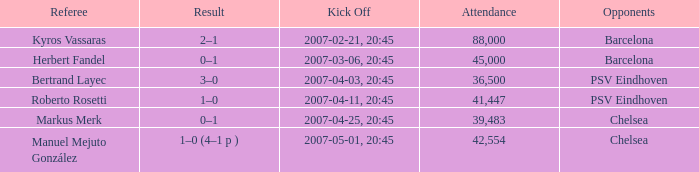WHAT WAS THE SCORE OF THE GAME WITH A 2007-03-06, 20:45 KICKOFF? 0–1. 